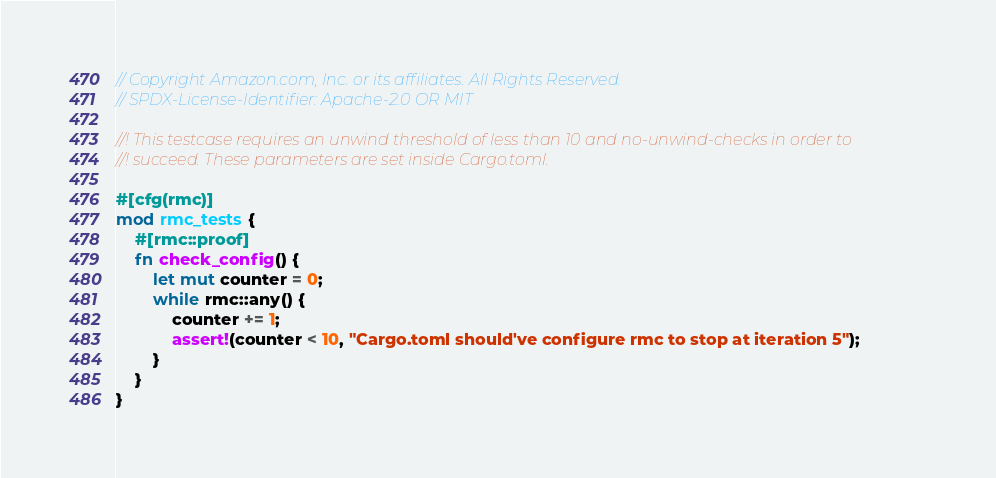Convert code to text. <code><loc_0><loc_0><loc_500><loc_500><_Rust_>// Copyright Amazon.com, Inc. or its affiliates. All Rights Reserved.
// SPDX-License-Identifier: Apache-2.0 OR MIT

//! This testcase requires an unwind threshold of less than 10 and no-unwind-checks in order to
//! succeed. These parameters are set inside Cargo.toml.

#[cfg(rmc)]
mod rmc_tests {
    #[rmc::proof]
    fn check_config() {
        let mut counter = 0;
        while rmc::any() {
            counter += 1;
            assert!(counter < 10, "Cargo.toml should've configure rmc to stop at iteration 5");
        }
    }
}
</code> 